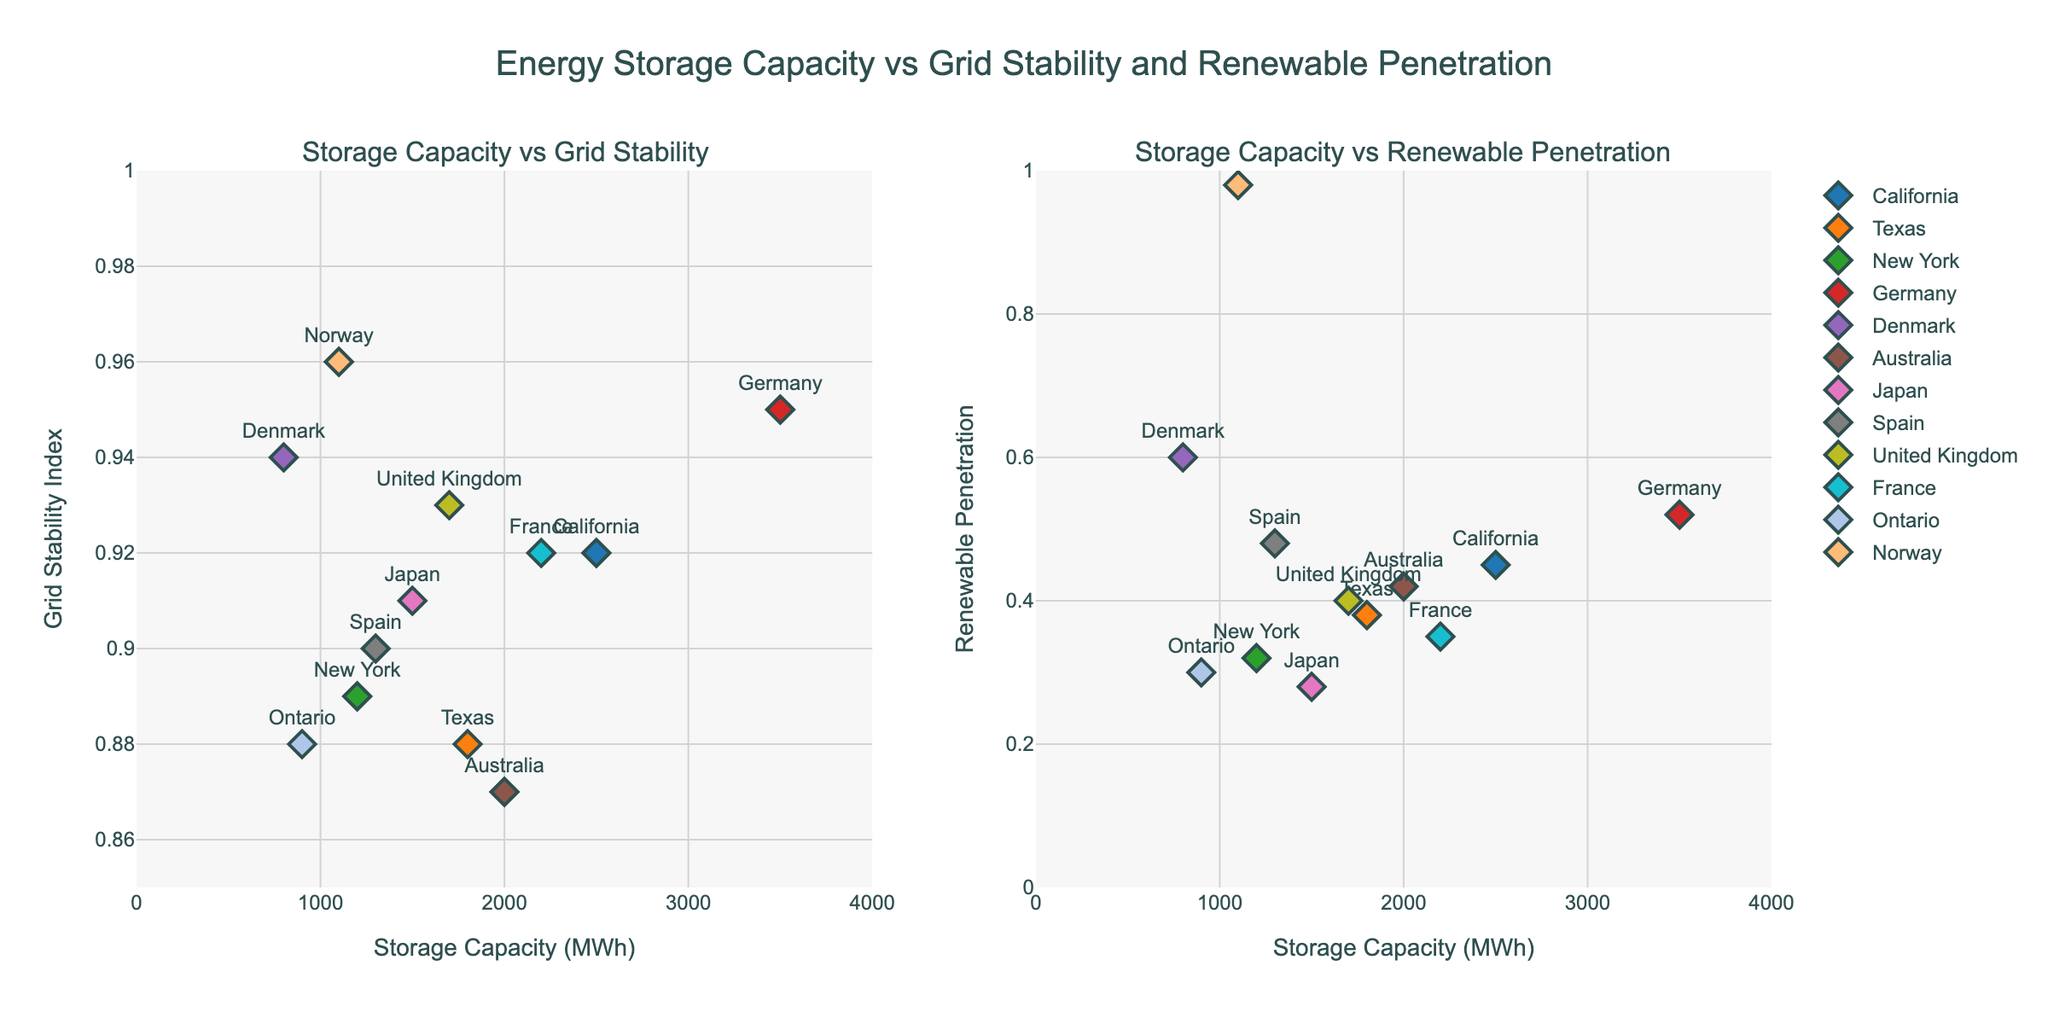What is the title of the figure? The title is displayed at the top center of the figure. It reads "Energy Storage Capacity vs Grid Stability and Renewable Penetration".
Answer: Energy Storage Capacity vs Grid Stability and Renewable Penetration How many regions are displayed in the figure? By observing the figure, you can count the number of unique data points labeled with regions. There are 12 regions in total.
Answer: 12 Which region has the highest Grid Stability Index? According to the "Storage Capacity vs Grid Stability" subplot, Norway has the highest index value, at 0.96.
Answer: Norway Which region has the highest Renewable Penetration? From the "Storage Capacity vs Renewable Penetration" subplot, Norway shows the highest Renewable Penetration, at 0.98.
Answer: Norway Which region has the lowest energy storage capacity? By comparing values on the x-axis of both subplots, Denmark has the lowest Storage Capacity at 800 MWh.
Answer: Denmark Compare the Storage Capacity and Grid Stability Index of Germany and California. Which one has better grid stability? Germany has a Storage Capacity of 3500 MWh and a Grid Stability Index of 0.95. California has a Storage Capacity of 2500 MWh and a Grid Stability Index of 0.92. Therefore, Germany has better grid stability.
Answer: Germany Which regions have a Grid Stability Index greater than 0.90? Referring to the "Storage Capacity vs Grid Stability" subplot, regions with a Grid Stability Index greater than 0.90 are California, Germany, Denmark, Japan, Spain, United Kingdom, France, and Norway.
Answer: California, Germany, Denmark, Japan, Spain, United Kingdom, France, Norway What is the average Renewable Penetration of Texas, New York, and France? Adding the Renewable Penetration values of Texas (0.38), New York (0.32), and France (0.35) gives 1.05. Dividing 1.05 by 3 yields an average of 0.35.
Answer: 0.35 What is the range of Storage Capacity values represented in the figure? The minimum and maximum values of Storage Capacity from the data points are 800 MWh (Denmark) and 3500 MWh (Germany). Therefore, the range is 800 to 3500 MWh.
Answer: 800 to 3500 MWh Identify the region with the lowest Renewable Penetration and provide its Grid Stability Index. Japan has the lowest Renewable Penetration at 0.28. Its Grid Stability Index is 0.91, as seen in the figure.
Answer: Japan, 0.91 